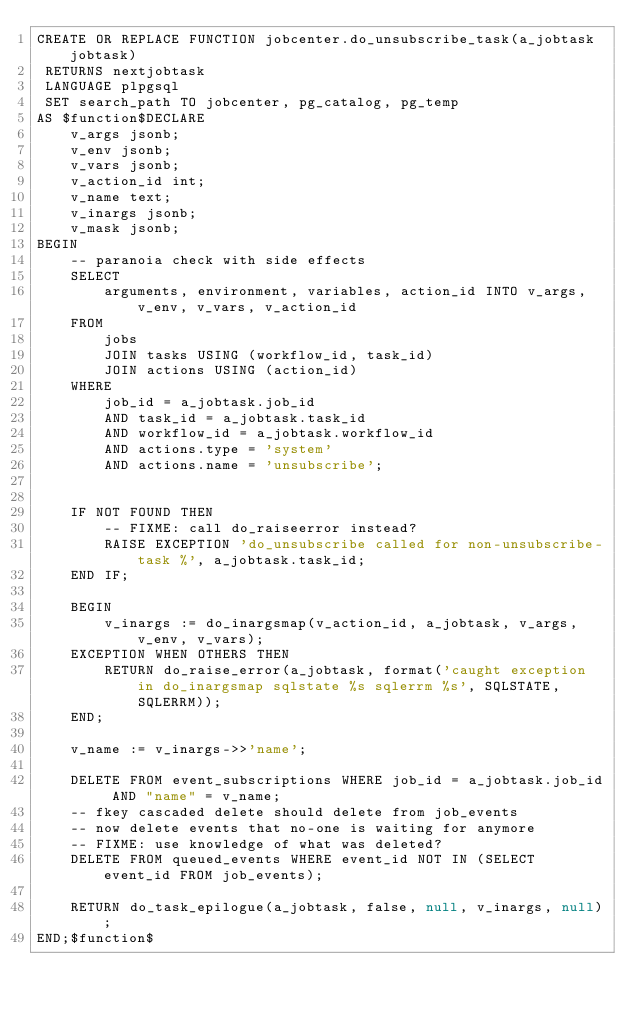<code> <loc_0><loc_0><loc_500><loc_500><_SQL_>CREATE OR REPLACE FUNCTION jobcenter.do_unsubscribe_task(a_jobtask jobtask)
 RETURNS nextjobtask
 LANGUAGE plpgsql
 SET search_path TO jobcenter, pg_catalog, pg_temp
AS $function$DECLARE
	v_args jsonb;
	v_env jsonb;
	v_vars jsonb;
	v_action_id int;
	v_name text;
	v_inargs jsonb;
	v_mask jsonb;
BEGIN
	-- paranoia check with side effects
	SELECT
		arguments, environment, variables, action_id INTO v_args, v_env, v_vars, v_action_id
	FROM
		jobs
		JOIN tasks USING (workflow_id, task_id)
		JOIN actions USING (action_id)
	WHERE
		job_id = a_jobtask.job_id
		AND task_id = a_jobtask.task_id
		AND workflow_id = a_jobtask.workflow_id
		AND actions.type = 'system'
		AND actions.name = 'unsubscribe';


	IF NOT FOUND THEN
		-- FIXME: call do_raiseerror instead?
		RAISE EXCEPTION 'do_unsubscribe called for non-unsubscribe-task %', a_jobtask.task_id;
	END IF;

	BEGIN
		v_inargs := do_inargsmap(v_action_id, a_jobtask, v_args, v_env, v_vars);
	EXCEPTION WHEN OTHERS THEN
		RETURN do_raise_error(a_jobtask, format('caught exception in do_inargsmap sqlstate %s sqlerrm %s', SQLSTATE, SQLERRM));
	END;
	
	v_name := v_inargs->>'name';

	DELETE FROM event_subscriptions WHERE job_id = a_jobtask.job_id AND "name" = v_name;
	-- fkey cascaded delete should delete from job_events
	-- now delete events that no-one is waiting for anymore
	-- FIXME: use knowledge of what was deleted?
	DELETE FROM queued_events WHERE event_id NOT IN (SELECT event_id FROM job_events);

	RETURN do_task_epilogue(a_jobtask, false, null, v_inargs, null);
END;$function$
</code> 